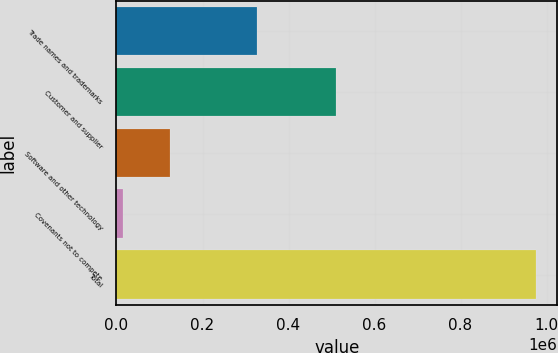<chart> <loc_0><loc_0><loc_500><loc_500><bar_chart><fcel>Trade names and trademarks<fcel>Customer and supplier<fcel>Software and other technology<fcel>Covenants not to compete<fcel>Total<nl><fcel>327332<fcel>510113<fcel>124049<fcel>14981<fcel>976475<nl></chart> 